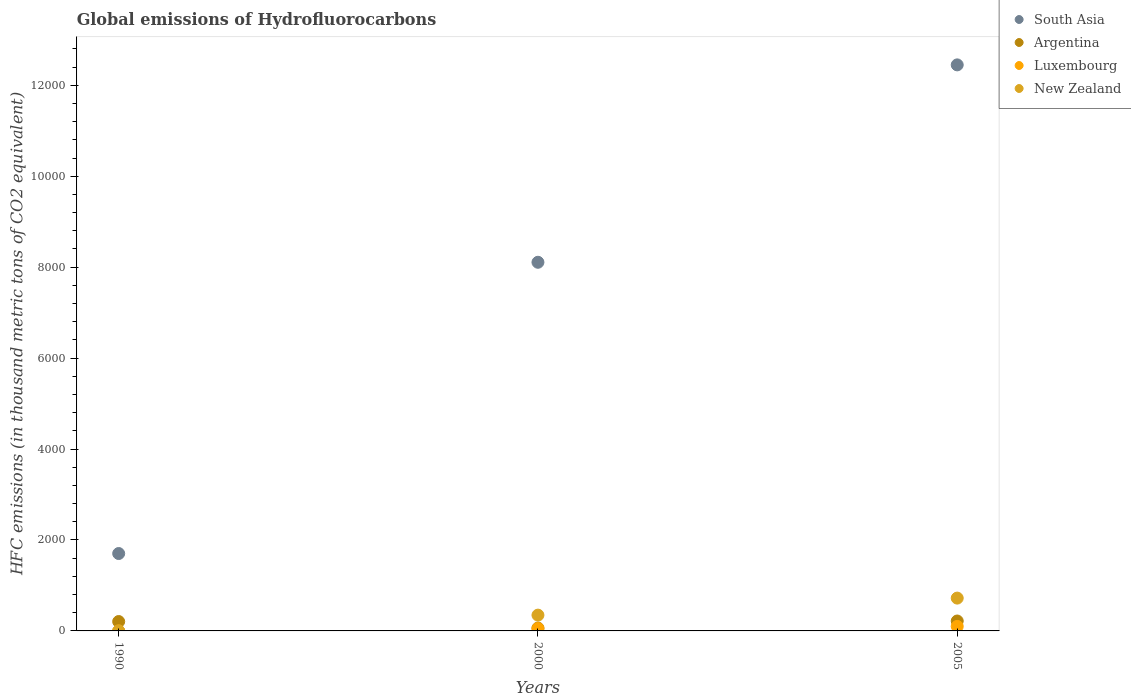How many different coloured dotlines are there?
Provide a short and direct response. 4. Is the number of dotlines equal to the number of legend labels?
Your answer should be very brief. Yes. What is the global emissions of Hydrofluorocarbons in Luxembourg in 2005?
Your answer should be very brief. 99.5. Across all years, what is the maximum global emissions of Hydrofluorocarbons in Argentina?
Give a very brief answer. 218.1. In which year was the global emissions of Hydrofluorocarbons in Argentina maximum?
Your answer should be compact. 2005. What is the total global emissions of Hydrofluorocarbons in Luxembourg in the graph?
Make the answer very short. 150.7. What is the difference between the global emissions of Hydrofluorocarbons in South Asia in 1990 and that in 2000?
Ensure brevity in your answer.  -6405.1. What is the difference between the global emissions of Hydrofluorocarbons in Luxembourg in 2000 and the global emissions of Hydrofluorocarbons in South Asia in 1990?
Make the answer very short. -1651. What is the average global emissions of Hydrofluorocarbons in Argentina per year?
Provide a succinct answer. 162.47. In the year 1990, what is the difference between the global emissions of Hydrofluorocarbons in New Zealand and global emissions of Hydrofluorocarbons in Argentina?
Your answer should be compact. -206.1. In how many years, is the global emissions of Hydrofluorocarbons in Argentina greater than 2800 thousand metric tons?
Offer a very short reply. 0. What is the ratio of the global emissions of Hydrofluorocarbons in Luxembourg in 2000 to that in 2005?
Offer a terse response. 0.51. Is the global emissions of Hydrofluorocarbons in South Asia in 1990 less than that in 2000?
Your answer should be compact. Yes. Is the difference between the global emissions of Hydrofluorocarbons in New Zealand in 1990 and 2000 greater than the difference between the global emissions of Hydrofluorocarbons in Argentina in 1990 and 2000?
Your answer should be compact. No. What is the difference between the highest and the second highest global emissions of Hydrofluorocarbons in New Zealand?
Your response must be concise. 374.4. What is the difference between the highest and the lowest global emissions of Hydrofluorocarbons in South Asia?
Provide a succinct answer. 1.07e+04. Is it the case that in every year, the sum of the global emissions of Hydrofluorocarbons in New Zealand and global emissions of Hydrofluorocarbons in South Asia  is greater than the sum of global emissions of Hydrofluorocarbons in Luxembourg and global emissions of Hydrofluorocarbons in Argentina?
Offer a very short reply. Yes. Is it the case that in every year, the sum of the global emissions of Hydrofluorocarbons in Argentina and global emissions of Hydrofluorocarbons in New Zealand  is greater than the global emissions of Hydrofluorocarbons in South Asia?
Offer a very short reply. No. Is the global emissions of Hydrofluorocarbons in New Zealand strictly greater than the global emissions of Hydrofluorocarbons in Luxembourg over the years?
Your answer should be compact. Yes. Is the global emissions of Hydrofluorocarbons in Argentina strictly less than the global emissions of Hydrofluorocarbons in New Zealand over the years?
Your answer should be very brief. No. How many dotlines are there?
Keep it short and to the point. 4. How many years are there in the graph?
Offer a very short reply. 3. What is the difference between two consecutive major ticks on the Y-axis?
Keep it short and to the point. 2000. Are the values on the major ticks of Y-axis written in scientific E-notation?
Offer a terse response. No. Does the graph contain any zero values?
Your answer should be very brief. No. Where does the legend appear in the graph?
Your answer should be compact. Top right. How many legend labels are there?
Your answer should be compact. 4. What is the title of the graph?
Offer a terse response. Global emissions of Hydrofluorocarbons. What is the label or title of the Y-axis?
Give a very brief answer. HFC emissions (in thousand metric tons of CO2 equivalent). What is the HFC emissions (in thousand metric tons of CO2 equivalent) in South Asia in 1990?
Your answer should be compact. 1702.1. What is the HFC emissions (in thousand metric tons of CO2 equivalent) in Argentina in 1990?
Offer a very short reply. 206.3. What is the HFC emissions (in thousand metric tons of CO2 equivalent) in Luxembourg in 1990?
Make the answer very short. 0.1. What is the HFC emissions (in thousand metric tons of CO2 equivalent) of South Asia in 2000?
Your answer should be compact. 8107.2. What is the HFC emissions (in thousand metric tons of CO2 equivalent) of Luxembourg in 2000?
Ensure brevity in your answer.  51.1. What is the HFC emissions (in thousand metric tons of CO2 equivalent) of New Zealand in 2000?
Your answer should be very brief. 347.3. What is the HFC emissions (in thousand metric tons of CO2 equivalent) of South Asia in 2005?
Your response must be concise. 1.24e+04. What is the HFC emissions (in thousand metric tons of CO2 equivalent) of Argentina in 2005?
Provide a succinct answer. 218.1. What is the HFC emissions (in thousand metric tons of CO2 equivalent) of Luxembourg in 2005?
Make the answer very short. 99.5. What is the HFC emissions (in thousand metric tons of CO2 equivalent) of New Zealand in 2005?
Ensure brevity in your answer.  721.7. Across all years, what is the maximum HFC emissions (in thousand metric tons of CO2 equivalent) in South Asia?
Your answer should be compact. 1.24e+04. Across all years, what is the maximum HFC emissions (in thousand metric tons of CO2 equivalent) in Argentina?
Provide a succinct answer. 218.1. Across all years, what is the maximum HFC emissions (in thousand metric tons of CO2 equivalent) in Luxembourg?
Offer a terse response. 99.5. Across all years, what is the maximum HFC emissions (in thousand metric tons of CO2 equivalent) of New Zealand?
Your response must be concise. 721.7. Across all years, what is the minimum HFC emissions (in thousand metric tons of CO2 equivalent) in South Asia?
Keep it short and to the point. 1702.1. Across all years, what is the minimum HFC emissions (in thousand metric tons of CO2 equivalent) in Argentina?
Provide a succinct answer. 63. Across all years, what is the minimum HFC emissions (in thousand metric tons of CO2 equivalent) of New Zealand?
Your response must be concise. 0.2. What is the total HFC emissions (in thousand metric tons of CO2 equivalent) in South Asia in the graph?
Provide a short and direct response. 2.23e+04. What is the total HFC emissions (in thousand metric tons of CO2 equivalent) of Argentina in the graph?
Give a very brief answer. 487.4. What is the total HFC emissions (in thousand metric tons of CO2 equivalent) of Luxembourg in the graph?
Your answer should be compact. 150.7. What is the total HFC emissions (in thousand metric tons of CO2 equivalent) in New Zealand in the graph?
Give a very brief answer. 1069.2. What is the difference between the HFC emissions (in thousand metric tons of CO2 equivalent) in South Asia in 1990 and that in 2000?
Offer a terse response. -6405.1. What is the difference between the HFC emissions (in thousand metric tons of CO2 equivalent) of Argentina in 1990 and that in 2000?
Your response must be concise. 143.3. What is the difference between the HFC emissions (in thousand metric tons of CO2 equivalent) in Luxembourg in 1990 and that in 2000?
Offer a very short reply. -51. What is the difference between the HFC emissions (in thousand metric tons of CO2 equivalent) in New Zealand in 1990 and that in 2000?
Your answer should be very brief. -347.1. What is the difference between the HFC emissions (in thousand metric tons of CO2 equivalent) of South Asia in 1990 and that in 2005?
Offer a very short reply. -1.07e+04. What is the difference between the HFC emissions (in thousand metric tons of CO2 equivalent) in Argentina in 1990 and that in 2005?
Give a very brief answer. -11.8. What is the difference between the HFC emissions (in thousand metric tons of CO2 equivalent) in Luxembourg in 1990 and that in 2005?
Give a very brief answer. -99.4. What is the difference between the HFC emissions (in thousand metric tons of CO2 equivalent) in New Zealand in 1990 and that in 2005?
Offer a very short reply. -721.5. What is the difference between the HFC emissions (in thousand metric tons of CO2 equivalent) in South Asia in 2000 and that in 2005?
Make the answer very short. -4341.26. What is the difference between the HFC emissions (in thousand metric tons of CO2 equivalent) of Argentina in 2000 and that in 2005?
Your answer should be compact. -155.1. What is the difference between the HFC emissions (in thousand metric tons of CO2 equivalent) of Luxembourg in 2000 and that in 2005?
Your response must be concise. -48.4. What is the difference between the HFC emissions (in thousand metric tons of CO2 equivalent) of New Zealand in 2000 and that in 2005?
Offer a terse response. -374.4. What is the difference between the HFC emissions (in thousand metric tons of CO2 equivalent) of South Asia in 1990 and the HFC emissions (in thousand metric tons of CO2 equivalent) of Argentina in 2000?
Offer a terse response. 1639.1. What is the difference between the HFC emissions (in thousand metric tons of CO2 equivalent) in South Asia in 1990 and the HFC emissions (in thousand metric tons of CO2 equivalent) in Luxembourg in 2000?
Offer a very short reply. 1651. What is the difference between the HFC emissions (in thousand metric tons of CO2 equivalent) in South Asia in 1990 and the HFC emissions (in thousand metric tons of CO2 equivalent) in New Zealand in 2000?
Ensure brevity in your answer.  1354.8. What is the difference between the HFC emissions (in thousand metric tons of CO2 equivalent) in Argentina in 1990 and the HFC emissions (in thousand metric tons of CO2 equivalent) in Luxembourg in 2000?
Provide a succinct answer. 155.2. What is the difference between the HFC emissions (in thousand metric tons of CO2 equivalent) in Argentina in 1990 and the HFC emissions (in thousand metric tons of CO2 equivalent) in New Zealand in 2000?
Your answer should be very brief. -141. What is the difference between the HFC emissions (in thousand metric tons of CO2 equivalent) of Luxembourg in 1990 and the HFC emissions (in thousand metric tons of CO2 equivalent) of New Zealand in 2000?
Your answer should be very brief. -347.2. What is the difference between the HFC emissions (in thousand metric tons of CO2 equivalent) of South Asia in 1990 and the HFC emissions (in thousand metric tons of CO2 equivalent) of Argentina in 2005?
Your answer should be compact. 1484. What is the difference between the HFC emissions (in thousand metric tons of CO2 equivalent) of South Asia in 1990 and the HFC emissions (in thousand metric tons of CO2 equivalent) of Luxembourg in 2005?
Keep it short and to the point. 1602.6. What is the difference between the HFC emissions (in thousand metric tons of CO2 equivalent) of South Asia in 1990 and the HFC emissions (in thousand metric tons of CO2 equivalent) of New Zealand in 2005?
Give a very brief answer. 980.4. What is the difference between the HFC emissions (in thousand metric tons of CO2 equivalent) in Argentina in 1990 and the HFC emissions (in thousand metric tons of CO2 equivalent) in Luxembourg in 2005?
Offer a terse response. 106.8. What is the difference between the HFC emissions (in thousand metric tons of CO2 equivalent) of Argentina in 1990 and the HFC emissions (in thousand metric tons of CO2 equivalent) of New Zealand in 2005?
Your answer should be very brief. -515.4. What is the difference between the HFC emissions (in thousand metric tons of CO2 equivalent) in Luxembourg in 1990 and the HFC emissions (in thousand metric tons of CO2 equivalent) in New Zealand in 2005?
Give a very brief answer. -721.6. What is the difference between the HFC emissions (in thousand metric tons of CO2 equivalent) in South Asia in 2000 and the HFC emissions (in thousand metric tons of CO2 equivalent) in Argentina in 2005?
Give a very brief answer. 7889.1. What is the difference between the HFC emissions (in thousand metric tons of CO2 equivalent) of South Asia in 2000 and the HFC emissions (in thousand metric tons of CO2 equivalent) of Luxembourg in 2005?
Offer a very short reply. 8007.7. What is the difference between the HFC emissions (in thousand metric tons of CO2 equivalent) in South Asia in 2000 and the HFC emissions (in thousand metric tons of CO2 equivalent) in New Zealand in 2005?
Your answer should be compact. 7385.5. What is the difference between the HFC emissions (in thousand metric tons of CO2 equivalent) of Argentina in 2000 and the HFC emissions (in thousand metric tons of CO2 equivalent) of Luxembourg in 2005?
Keep it short and to the point. -36.5. What is the difference between the HFC emissions (in thousand metric tons of CO2 equivalent) of Argentina in 2000 and the HFC emissions (in thousand metric tons of CO2 equivalent) of New Zealand in 2005?
Make the answer very short. -658.7. What is the difference between the HFC emissions (in thousand metric tons of CO2 equivalent) of Luxembourg in 2000 and the HFC emissions (in thousand metric tons of CO2 equivalent) of New Zealand in 2005?
Give a very brief answer. -670.6. What is the average HFC emissions (in thousand metric tons of CO2 equivalent) of South Asia per year?
Give a very brief answer. 7419.25. What is the average HFC emissions (in thousand metric tons of CO2 equivalent) in Argentina per year?
Your answer should be very brief. 162.47. What is the average HFC emissions (in thousand metric tons of CO2 equivalent) of Luxembourg per year?
Your answer should be compact. 50.23. What is the average HFC emissions (in thousand metric tons of CO2 equivalent) in New Zealand per year?
Offer a very short reply. 356.4. In the year 1990, what is the difference between the HFC emissions (in thousand metric tons of CO2 equivalent) of South Asia and HFC emissions (in thousand metric tons of CO2 equivalent) of Argentina?
Keep it short and to the point. 1495.8. In the year 1990, what is the difference between the HFC emissions (in thousand metric tons of CO2 equivalent) in South Asia and HFC emissions (in thousand metric tons of CO2 equivalent) in Luxembourg?
Offer a very short reply. 1702. In the year 1990, what is the difference between the HFC emissions (in thousand metric tons of CO2 equivalent) in South Asia and HFC emissions (in thousand metric tons of CO2 equivalent) in New Zealand?
Your response must be concise. 1701.9. In the year 1990, what is the difference between the HFC emissions (in thousand metric tons of CO2 equivalent) of Argentina and HFC emissions (in thousand metric tons of CO2 equivalent) of Luxembourg?
Provide a short and direct response. 206.2. In the year 1990, what is the difference between the HFC emissions (in thousand metric tons of CO2 equivalent) in Argentina and HFC emissions (in thousand metric tons of CO2 equivalent) in New Zealand?
Give a very brief answer. 206.1. In the year 1990, what is the difference between the HFC emissions (in thousand metric tons of CO2 equivalent) in Luxembourg and HFC emissions (in thousand metric tons of CO2 equivalent) in New Zealand?
Offer a terse response. -0.1. In the year 2000, what is the difference between the HFC emissions (in thousand metric tons of CO2 equivalent) in South Asia and HFC emissions (in thousand metric tons of CO2 equivalent) in Argentina?
Offer a very short reply. 8044.2. In the year 2000, what is the difference between the HFC emissions (in thousand metric tons of CO2 equivalent) in South Asia and HFC emissions (in thousand metric tons of CO2 equivalent) in Luxembourg?
Offer a terse response. 8056.1. In the year 2000, what is the difference between the HFC emissions (in thousand metric tons of CO2 equivalent) of South Asia and HFC emissions (in thousand metric tons of CO2 equivalent) of New Zealand?
Give a very brief answer. 7759.9. In the year 2000, what is the difference between the HFC emissions (in thousand metric tons of CO2 equivalent) in Argentina and HFC emissions (in thousand metric tons of CO2 equivalent) in Luxembourg?
Your answer should be compact. 11.9. In the year 2000, what is the difference between the HFC emissions (in thousand metric tons of CO2 equivalent) of Argentina and HFC emissions (in thousand metric tons of CO2 equivalent) of New Zealand?
Your response must be concise. -284.3. In the year 2000, what is the difference between the HFC emissions (in thousand metric tons of CO2 equivalent) in Luxembourg and HFC emissions (in thousand metric tons of CO2 equivalent) in New Zealand?
Keep it short and to the point. -296.2. In the year 2005, what is the difference between the HFC emissions (in thousand metric tons of CO2 equivalent) of South Asia and HFC emissions (in thousand metric tons of CO2 equivalent) of Argentina?
Ensure brevity in your answer.  1.22e+04. In the year 2005, what is the difference between the HFC emissions (in thousand metric tons of CO2 equivalent) of South Asia and HFC emissions (in thousand metric tons of CO2 equivalent) of Luxembourg?
Ensure brevity in your answer.  1.23e+04. In the year 2005, what is the difference between the HFC emissions (in thousand metric tons of CO2 equivalent) of South Asia and HFC emissions (in thousand metric tons of CO2 equivalent) of New Zealand?
Offer a terse response. 1.17e+04. In the year 2005, what is the difference between the HFC emissions (in thousand metric tons of CO2 equivalent) of Argentina and HFC emissions (in thousand metric tons of CO2 equivalent) of Luxembourg?
Give a very brief answer. 118.6. In the year 2005, what is the difference between the HFC emissions (in thousand metric tons of CO2 equivalent) in Argentina and HFC emissions (in thousand metric tons of CO2 equivalent) in New Zealand?
Keep it short and to the point. -503.6. In the year 2005, what is the difference between the HFC emissions (in thousand metric tons of CO2 equivalent) of Luxembourg and HFC emissions (in thousand metric tons of CO2 equivalent) of New Zealand?
Your response must be concise. -622.2. What is the ratio of the HFC emissions (in thousand metric tons of CO2 equivalent) in South Asia in 1990 to that in 2000?
Your answer should be compact. 0.21. What is the ratio of the HFC emissions (in thousand metric tons of CO2 equivalent) of Argentina in 1990 to that in 2000?
Your answer should be very brief. 3.27. What is the ratio of the HFC emissions (in thousand metric tons of CO2 equivalent) of Luxembourg in 1990 to that in 2000?
Offer a very short reply. 0. What is the ratio of the HFC emissions (in thousand metric tons of CO2 equivalent) of New Zealand in 1990 to that in 2000?
Ensure brevity in your answer.  0. What is the ratio of the HFC emissions (in thousand metric tons of CO2 equivalent) in South Asia in 1990 to that in 2005?
Ensure brevity in your answer.  0.14. What is the ratio of the HFC emissions (in thousand metric tons of CO2 equivalent) in Argentina in 1990 to that in 2005?
Ensure brevity in your answer.  0.95. What is the ratio of the HFC emissions (in thousand metric tons of CO2 equivalent) in Luxembourg in 1990 to that in 2005?
Offer a very short reply. 0. What is the ratio of the HFC emissions (in thousand metric tons of CO2 equivalent) of South Asia in 2000 to that in 2005?
Provide a short and direct response. 0.65. What is the ratio of the HFC emissions (in thousand metric tons of CO2 equivalent) of Argentina in 2000 to that in 2005?
Ensure brevity in your answer.  0.29. What is the ratio of the HFC emissions (in thousand metric tons of CO2 equivalent) in Luxembourg in 2000 to that in 2005?
Ensure brevity in your answer.  0.51. What is the ratio of the HFC emissions (in thousand metric tons of CO2 equivalent) of New Zealand in 2000 to that in 2005?
Keep it short and to the point. 0.48. What is the difference between the highest and the second highest HFC emissions (in thousand metric tons of CO2 equivalent) of South Asia?
Your answer should be compact. 4341.26. What is the difference between the highest and the second highest HFC emissions (in thousand metric tons of CO2 equivalent) of Luxembourg?
Ensure brevity in your answer.  48.4. What is the difference between the highest and the second highest HFC emissions (in thousand metric tons of CO2 equivalent) in New Zealand?
Your response must be concise. 374.4. What is the difference between the highest and the lowest HFC emissions (in thousand metric tons of CO2 equivalent) of South Asia?
Give a very brief answer. 1.07e+04. What is the difference between the highest and the lowest HFC emissions (in thousand metric tons of CO2 equivalent) in Argentina?
Provide a short and direct response. 155.1. What is the difference between the highest and the lowest HFC emissions (in thousand metric tons of CO2 equivalent) in Luxembourg?
Provide a succinct answer. 99.4. What is the difference between the highest and the lowest HFC emissions (in thousand metric tons of CO2 equivalent) in New Zealand?
Offer a terse response. 721.5. 